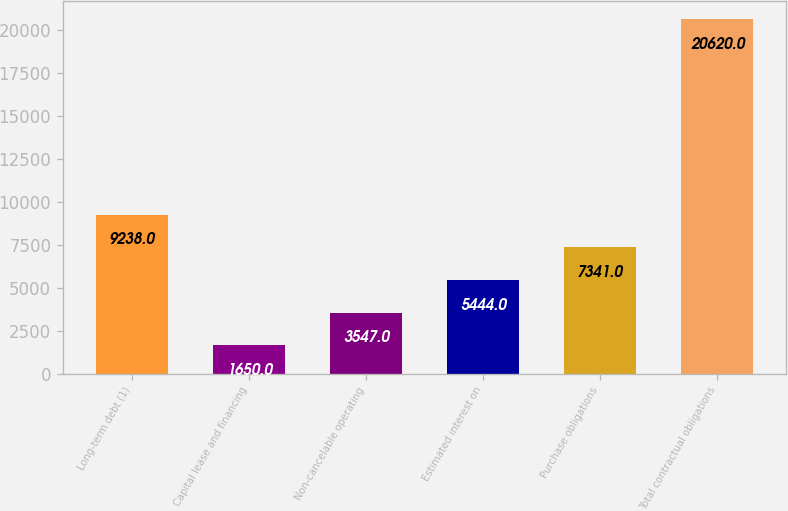Convert chart. <chart><loc_0><loc_0><loc_500><loc_500><bar_chart><fcel>Long-term debt (1)<fcel>Capital lease and financing<fcel>Non-cancelable operating<fcel>Estimated interest on<fcel>Purchase obligations<fcel>Total contractual obligations<nl><fcel>9238<fcel>1650<fcel>3547<fcel>5444<fcel>7341<fcel>20620<nl></chart> 